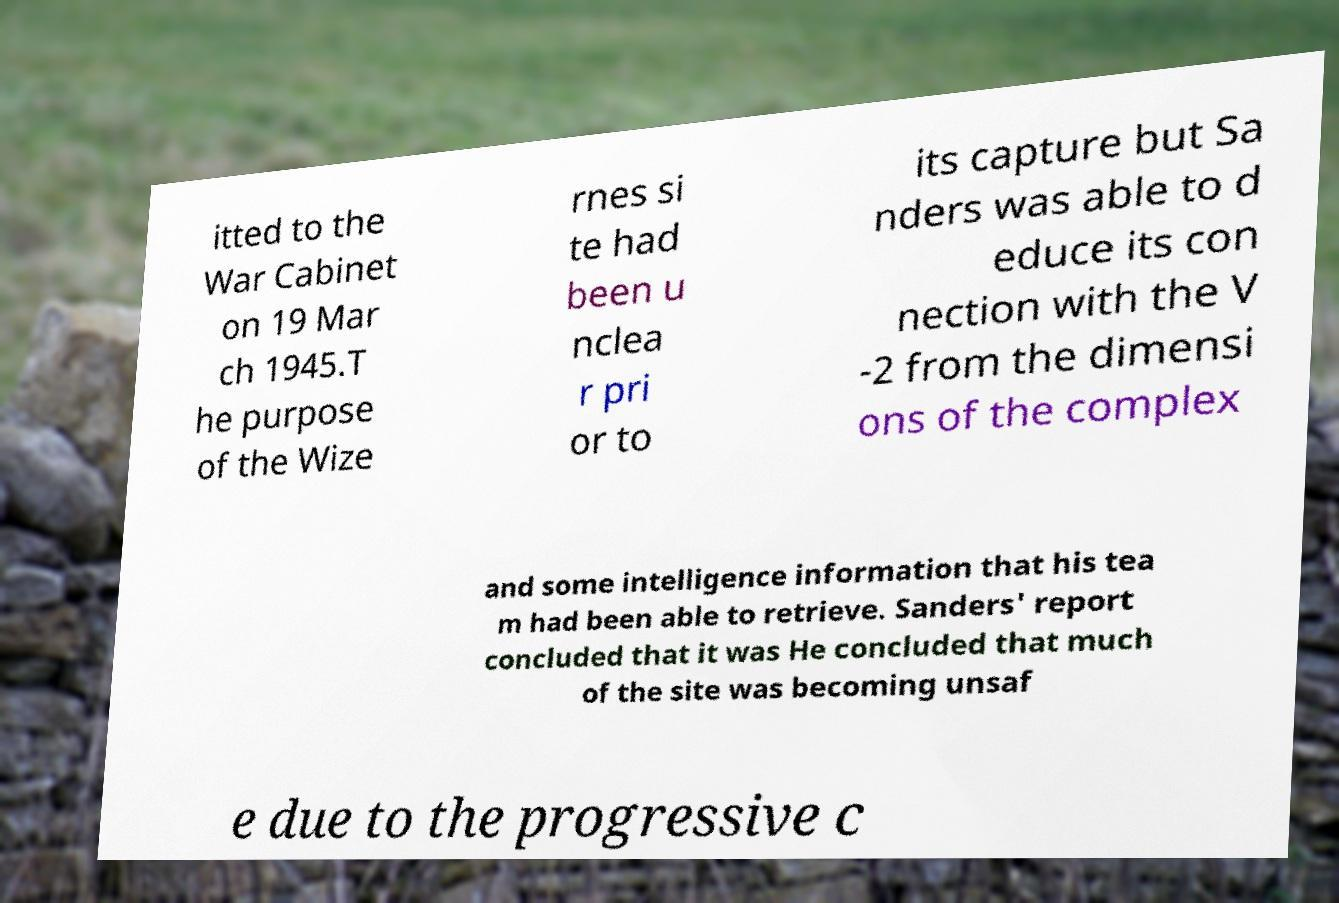Please read and relay the text visible in this image. What does it say? itted to the War Cabinet on 19 Mar ch 1945.T he purpose of the Wize rnes si te had been u nclea r pri or to its capture but Sa nders was able to d educe its con nection with the V -2 from the dimensi ons of the complex and some intelligence information that his tea m had been able to retrieve. Sanders' report concluded that it was He concluded that much of the site was becoming unsaf e due to the progressive c 